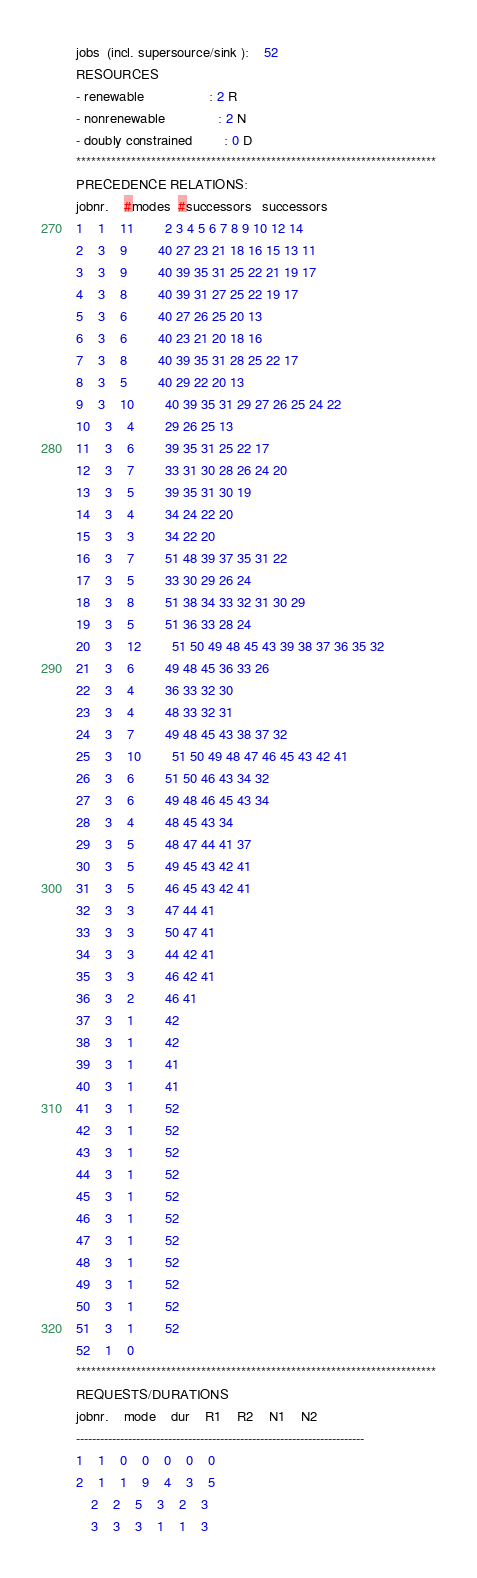Convert code to text. <code><loc_0><loc_0><loc_500><loc_500><_ObjectiveC_>jobs  (incl. supersource/sink ):	52
RESOURCES
- renewable                 : 2 R
- nonrenewable              : 2 N
- doubly constrained        : 0 D
************************************************************************
PRECEDENCE RELATIONS:
jobnr.    #modes  #successors   successors
1	1	11		2 3 4 5 6 7 8 9 10 12 14 
2	3	9		40 27 23 21 18 16 15 13 11 
3	3	9		40 39 35 31 25 22 21 19 17 
4	3	8		40 39 31 27 25 22 19 17 
5	3	6		40 27 26 25 20 13 
6	3	6		40 23 21 20 18 16 
7	3	8		40 39 35 31 28 25 22 17 
8	3	5		40 29 22 20 13 
9	3	10		40 39 35 31 29 27 26 25 24 22 
10	3	4		29 26 25 13 
11	3	6		39 35 31 25 22 17 
12	3	7		33 31 30 28 26 24 20 
13	3	5		39 35 31 30 19 
14	3	4		34 24 22 20 
15	3	3		34 22 20 
16	3	7		51 48 39 37 35 31 22 
17	3	5		33 30 29 26 24 
18	3	8		51 38 34 33 32 31 30 29 
19	3	5		51 36 33 28 24 
20	3	12		51 50 49 48 45 43 39 38 37 36 35 32 
21	3	6		49 48 45 36 33 26 
22	3	4		36 33 32 30 
23	3	4		48 33 32 31 
24	3	7		49 48 45 43 38 37 32 
25	3	10		51 50 49 48 47 46 45 43 42 41 
26	3	6		51 50 46 43 34 32 
27	3	6		49 48 46 45 43 34 
28	3	4		48 45 43 34 
29	3	5		48 47 44 41 37 
30	3	5		49 45 43 42 41 
31	3	5		46 45 43 42 41 
32	3	3		47 44 41 
33	3	3		50 47 41 
34	3	3		44 42 41 
35	3	3		46 42 41 
36	3	2		46 41 
37	3	1		42 
38	3	1		42 
39	3	1		41 
40	3	1		41 
41	3	1		52 
42	3	1		52 
43	3	1		52 
44	3	1		52 
45	3	1		52 
46	3	1		52 
47	3	1		52 
48	3	1		52 
49	3	1		52 
50	3	1		52 
51	3	1		52 
52	1	0		
************************************************************************
REQUESTS/DURATIONS
jobnr.	mode	dur	R1	R2	N1	N2	
------------------------------------------------------------------------
1	1	0	0	0	0	0	
2	1	1	9	4	3	5	
	2	2	5	3	2	3	
	3	3	3	1	1	3	</code> 